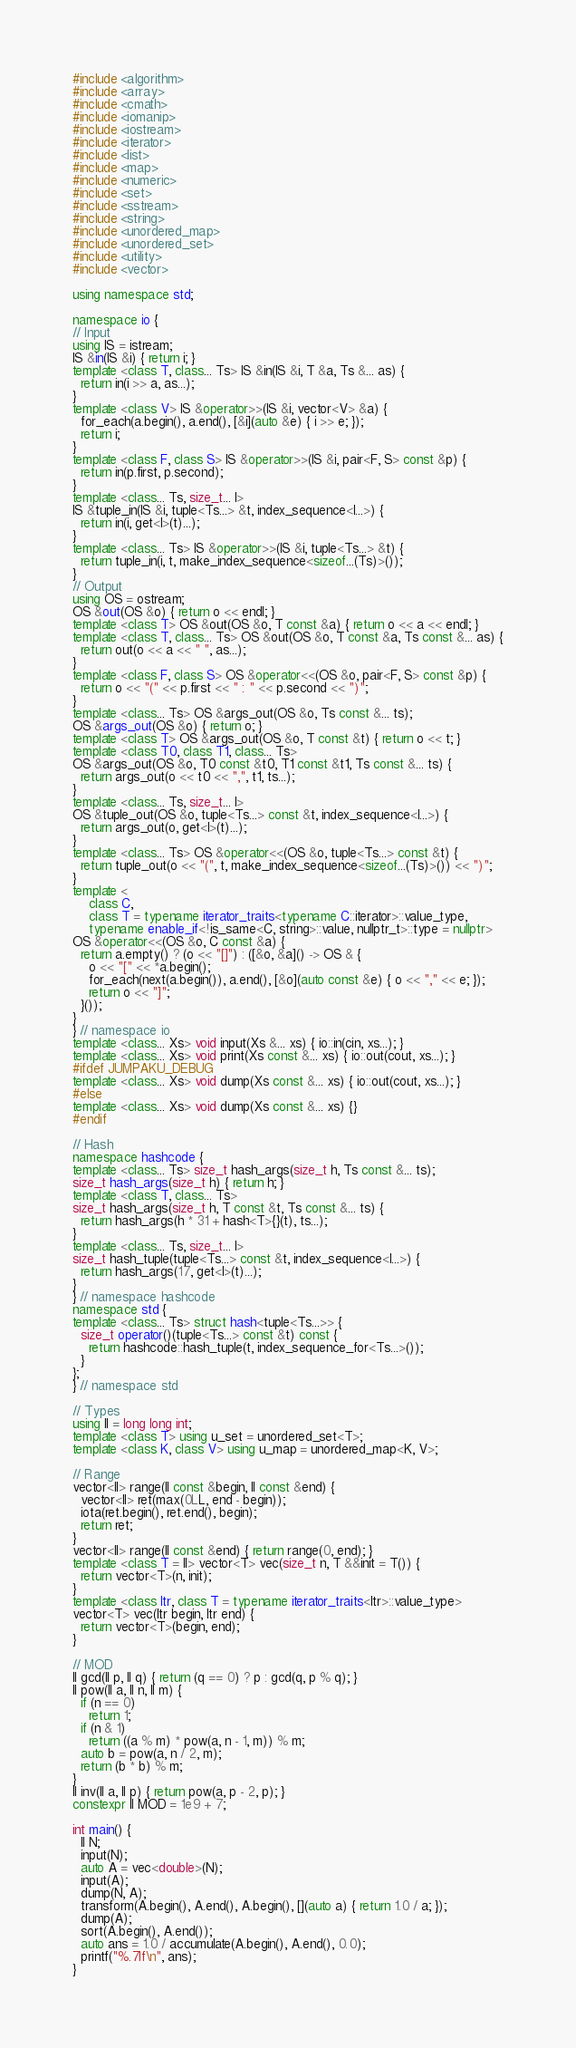<code> <loc_0><loc_0><loc_500><loc_500><_C++_>#include <algorithm>
#include <array>
#include <cmath>
#include <iomanip>
#include <iostream>
#include <iterator>
#include <list>
#include <map>
#include <numeric>
#include <set>
#include <sstream>
#include <string>
#include <unordered_map>
#include <unordered_set>
#include <utility>
#include <vector>

using namespace std;

namespace io {
// Input
using IS = istream;
IS &in(IS &i) { return i; }
template <class T, class... Ts> IS &in(IS &i, T &a, Ts &... as) {
  return in(i >> a, as...);
}
template <class V> IS &operator>>(IS &i, vector<V> &a) {
  for_each(a.begin(), a.end(), [&i](auto &e) { i >> e; });
  return i;
}
template <class F, class S> IS &operator>>(IS &i, pair<F, S> const &p) {
  return in(p.first, p.second);
}
template <class... Ts, size_t... I>
IS &tuple_in(IS &i, tuple<Ts...> &t, index_sequence<I...>) {
  return in(i, get<I>(t)...);
}
template <class... Ts> IS &operator>>(IS &i, tuple<Ts...> &t) {
  return tuple_in(i, t, make_index_sequence<sizeof...(Ts)>());
}
// Output
using OS = ostream;
OS &out(OS &o) { return o << endl; }
template <class T> OS &out(OS &o, T const &a) { return o << a << endl; }
template <class T, class... Ts> OS &out(OS &o, T const &a, Ts const &... as) {
  return out(o << a << " ", as...);
}
template <class F, class S> OS &operator<<(OS &o, pair<F, S> const &p) {
  return o << "(" << p.first << " : " << p.second << ")";
}
template <class... Ts> OS &args_out(OS &o, Ts const &... ts);
OS &args_out(OS &o) { return o; }
template <class T> OS &args_out(OS &o, T const &t) { return o << t; }
template <class T0, class T1, class... Ts>
OS &args_out(OS &o, T0 const &t0, T1 const &t1, Ts const &... ts) {
  return args_out(o << t0 << ",", t1, ts...);
}
template <class... Ts, size_t... I>
OS &tuple_out(OS &o, tuple<Ts...> const &t, index_sequence<I...>) {
  return args_out(o, get<I>(t)...);
}
template <class... Ts> OS &operator<<(OS &o, tuple<Ts...> const &t) {
  return tuple_out(o << "(", t, make_index_sequence<sizeof...(Ts)>()) << ")";
}
template <
    class C,
    class T = typename iterator_traits<typename C::iterator>::value_type,
    typename enable_if<!is_same<C, string>::value, nullptr_t>::type = nullptr>
OS &operator<<(OS &o, C const &a) {
  return a.empty() ? (o << "[]") : ([&o, &a]() -> OS & {
    o << "[" << *a.begin();
    for_each(next(a.begin()), a.end(), [&o](auto const &e) { o << "," << e; });
    return o << "]";
  }());
}
} // namespace io
template <class... Xs> void input(Xs &... xs) { io::in(cin, xs...); }
template <class... Xs> void print(Xs const &... xs) { io::out(cout, xs...); }
#ifdef JUMPAKU_DEBUG
template <class... Xs> void dump(Xs const &... xs) { io::out(cout, xs...); }
#else
template <class... Xs> void dump(Xs const &... xs) {}
#endif

// Hash
namespace hashcode {
template <class... Ts> size_t hash_args(size_t h, Ts const &... ts);
size_t hash_args(size_t h) { return h; }
template <class T, class... Ts>
size_t hash_args(size_t h, T const &t, Ts const &... ts) {
  return hash_args(h * 31 + hash<T>{}(t), ts...);
}
template <class... Ts, size_t... I>
size_t hash_tuple(tuple<Ts...> const &t, index_sequence<I...>) {
  return hash_args(17, get<I>(t)...);
}
} // namespace hashcode
namespace std {
template <class... Ts> struct hash<tuple<Ts...>> {
  size_t operator()(tuple<Ts...> const &t) const {
    return hashcode::hash_tuple(t, index_sequence_for<Ts...>());
  }
};
} // namespace std

// Types
using ll = long long int;
template <class T> using u_set = unordered_set<T>;
template <class K, class V> using u_map = unordered_map<K, V>;

// Range
vector<ll> range(ll const &begin, ll const &end) {
  vector<ll> ret(max(0LL, end - begin));
  iota(ret.begin(), ret.end(), begin);
  return ret;
}
vector<ll> range(ll const &end) { return range(0, end); }
template <class T = ll> vector<T> vec(size_t n, T &&init = T()) {
  return vector<T>(n, init);
}
template <class Itr, class T = typename iterator_traits<Itr>::value_type>
vector<T> vec(Itr begin, Itr end) {
  return vector<T>(begin, end);
}

// MOD
ll gcd(ll p, ll q) { return (q == 0) ? p : gcd(q, p % q); }
ll pow(ll a, ll n, ll m) {
  if (n == 0)
    return 1;
  if (n & 1)
    return ((a % m) * pow(a, n - 1, m)) % m;
  auto b = pow(a, n / 2, m);
  return (b * b) % m;
}
ll inv(ll a, ll p) { return pow(a, p - 2, p); }
constexpr ll MOD = 1e9 + 7;

int main() {
  ll N;
  input(N);
  auto A = vec<double>(N);
  input(A);
  dump(N, A);
  transform(A.begin(), A.end(), A.begin(), [](auto a) { return 1.0 / a; });
  dump(A);
  sort(A.begin(), A.end());
  auto ans = 1.0 / accumulate(A.begin(), A.end(), 0.0);
  printf("%.7lf\n", ans);
}
</code> 